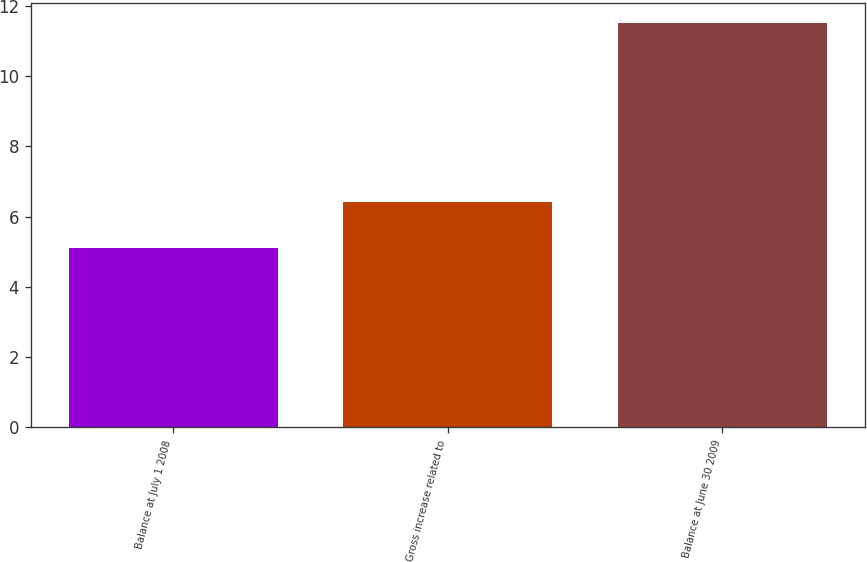<chart> <loc_0><loc_0><loc_500><loc_500><bar_chart><fcel>Balance at July 1 2008<fcel>Gross increase related to<fcel>Balance at June 30 2009<nl><fcel>5.1<fcel>6.4<fcel>11.5<nl></chart> 